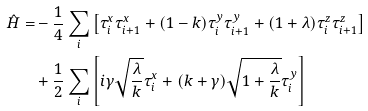<formula> <loc_0><loc_0><loc_500><loc_500>\hat { H } = & - \frac { 1 } { 4 } \sum _ { i } \left [ \tau _ { i } ^ { x } \tau _ { i + 1 } ^ { x } + ( 1 - k ) \tau _ { i } ^ { y } \tau _ { i + 1 } ^ { y } + ( 1 + \lambda ) \tau _ { i } ^ { z } \tau _ { i + 1 } ^ { z } \right ] \\ & + \frac { 1 } { 2 } \sum _ { i } \left [ i \gamma \sqrt { \frac { \lambda } { k } } \tau _ { i } ^ { x } + ( k + \gamma ) \sqrt { 1 + \frac { \lambda } { k } } \tau _ { i } ^ { y } \right ]</formula> 